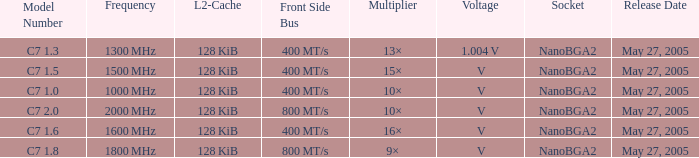What is the Frequency for Model Number c7 1.0? 1000 MHz. 